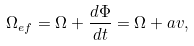Convert formula to latex. <formula><loc_0><loc_0><loc_500><loc_500>\Omega _ { e f } = \Omega + \frac { d \Phi } { d t } = \Omega + a v ,</formula> 